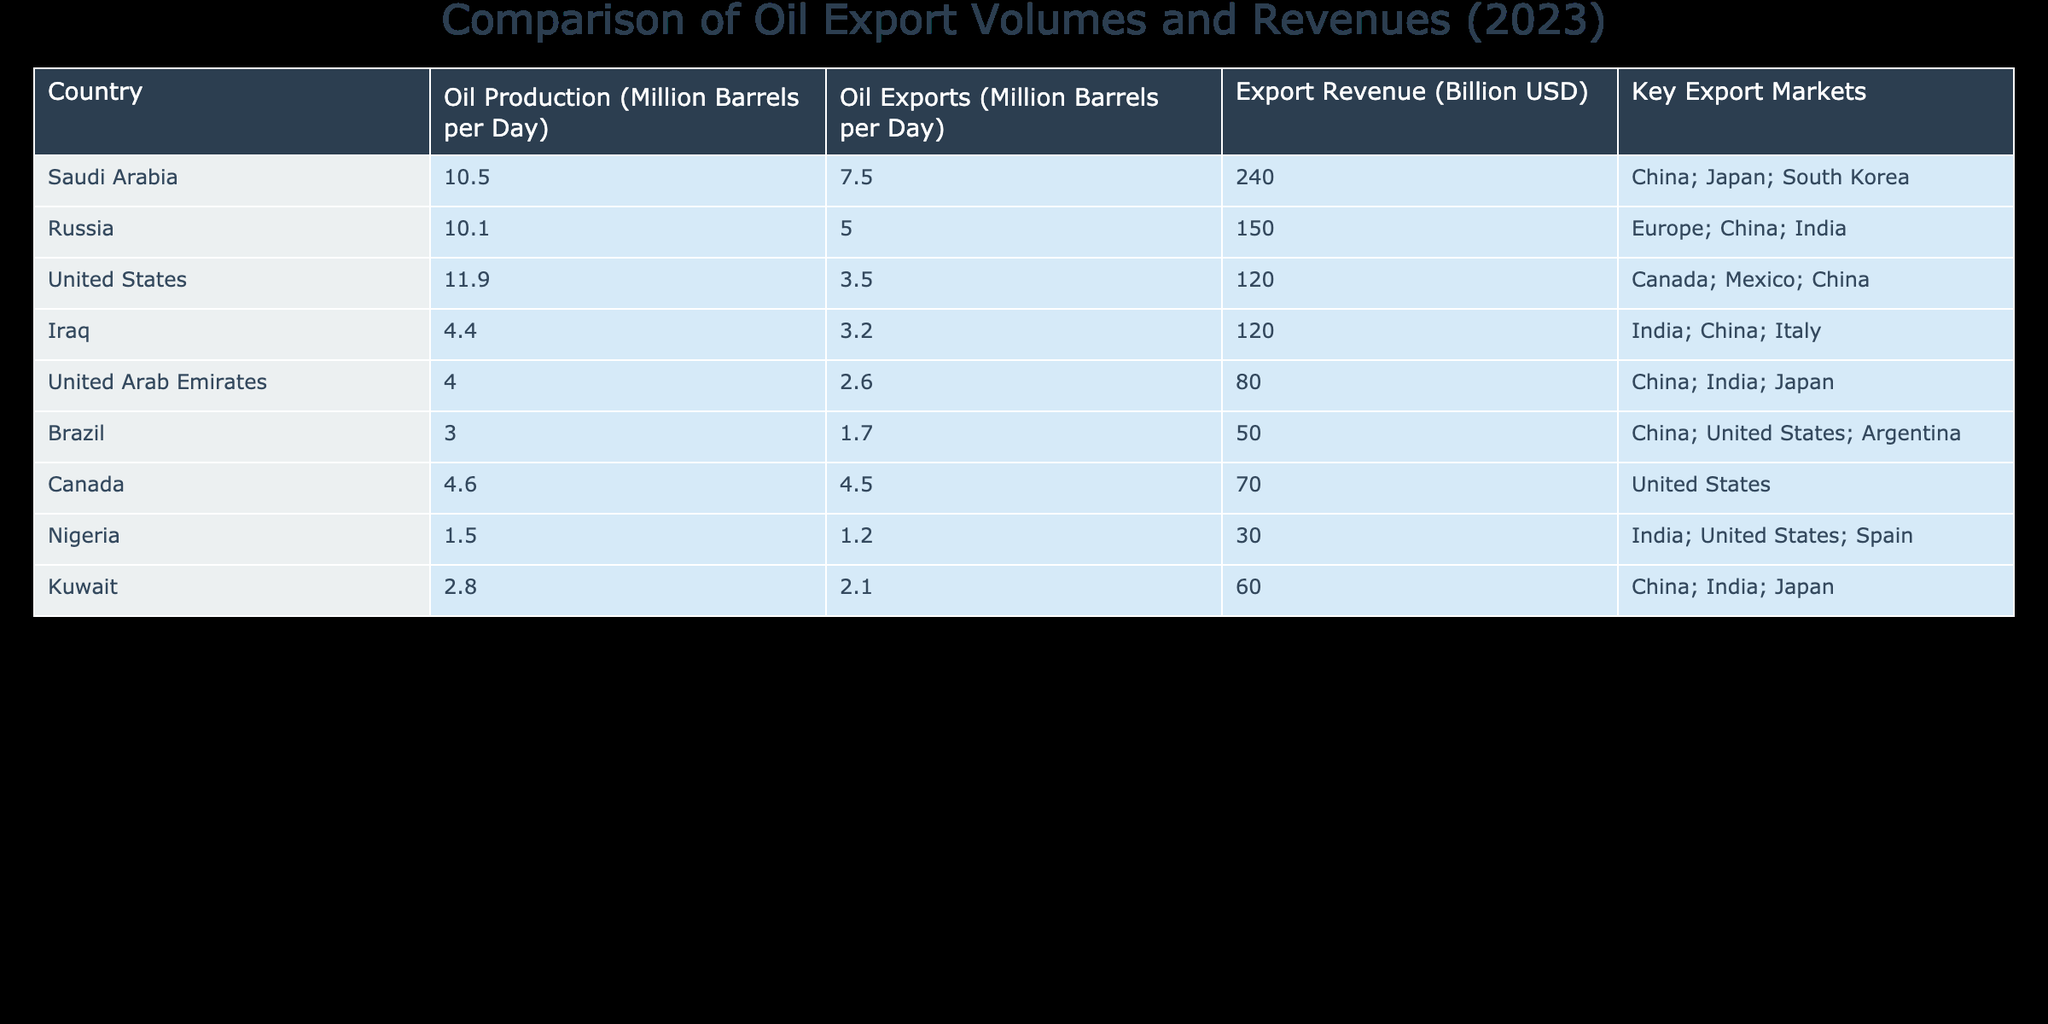What country has the highest oil production in million barrels per day? By examining the 'Oil Production' column of the table, I can see that Saudi Arabia has the highest value at 10.5 million barrels per day.
Answer: Saudi Arabia Which country has the lowest export revenue in billion USD? Looking at the 'Export Revenue' column, Nigeria has the lowest value at 30 billion USD in comparison to the other countries listed.
Answer: Nigeria What is the total oil export volume for the top three oil-exporting countries? The top three oil-exporting countries are Saudi Arabia (7.5), Russia (5.0), and Iraq (3.2). Adding these values gives 7.5 + 5.0 + 3.2 = 15.7 million barrels per day.
Answer: 15.7 million barrels per day Is it true that the United States is among the top four countries by oil export volume? By checking the 'Oil Exports' column, the United States exports 3.5 million barrels per day, which ranks it lower than the top four countries (Saudi Arabia, Russia, and Iraq). Therefore, this statement is false.
Answer: No What percentage of total oil exports is contributed by the United Arab Emirates? The total oil exports (sum of all export volumes) is 7.5 + 5.0 + 3.5 + 3.2 + 2.6 + 1.7 + 4.5 + 1.2 + 2.1 = 31.6 million barrels per day. The UAE exports 2.6 million barrels per day, so the percentage is (2.6 / 31.6) * 100 = approx. 8.23%.
Answer: 8.23% Which country exports more oil than it produces? By comparing the 'Oil Production' and 'Oil Exports' columns, Canada has an oil export volume of 4.5 million barrels per day while having a production of 4.6 million barrels per day. Therefore, no single country exports more than it produces.
Answer: No How many countries have export revenues of over 100 billion USD? By reviewing the 'Export Revenue' column, Saudi Arabia (240), Russia (150), and Iraq (120) have revenues above 100 billion USD. Counting these, there are three countries.
Answer: 3 Which country has the highest oil exports to China? From the 'Key Export Markets' column, Saudi Arabia, Russia, and the UAE all list China as a key market. However, Saudi Arabia has the highest oil export volume at 7.5 million barrels per day, making it the country with the highest exports to China.
Answer: Saudi Arabia 